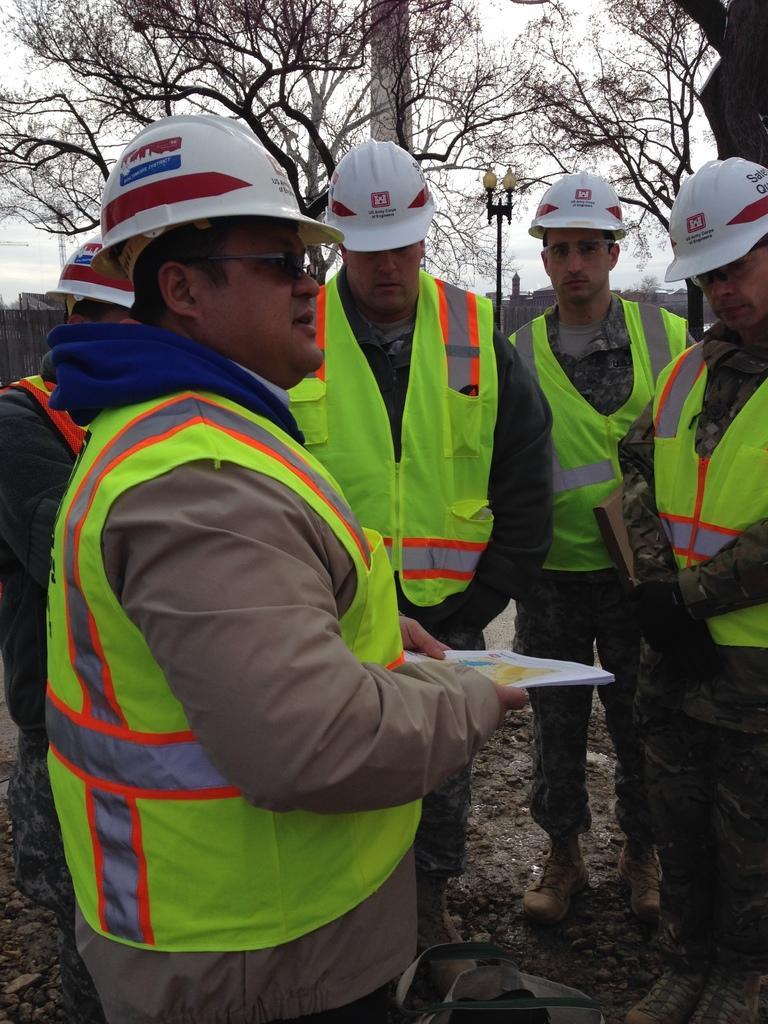Can you describe this image briefly? In this image we can see a few people wearing caps and standing, among them two are holding the objects, there are some trees, poles, lights and buildings, in the background we can see the sky. 